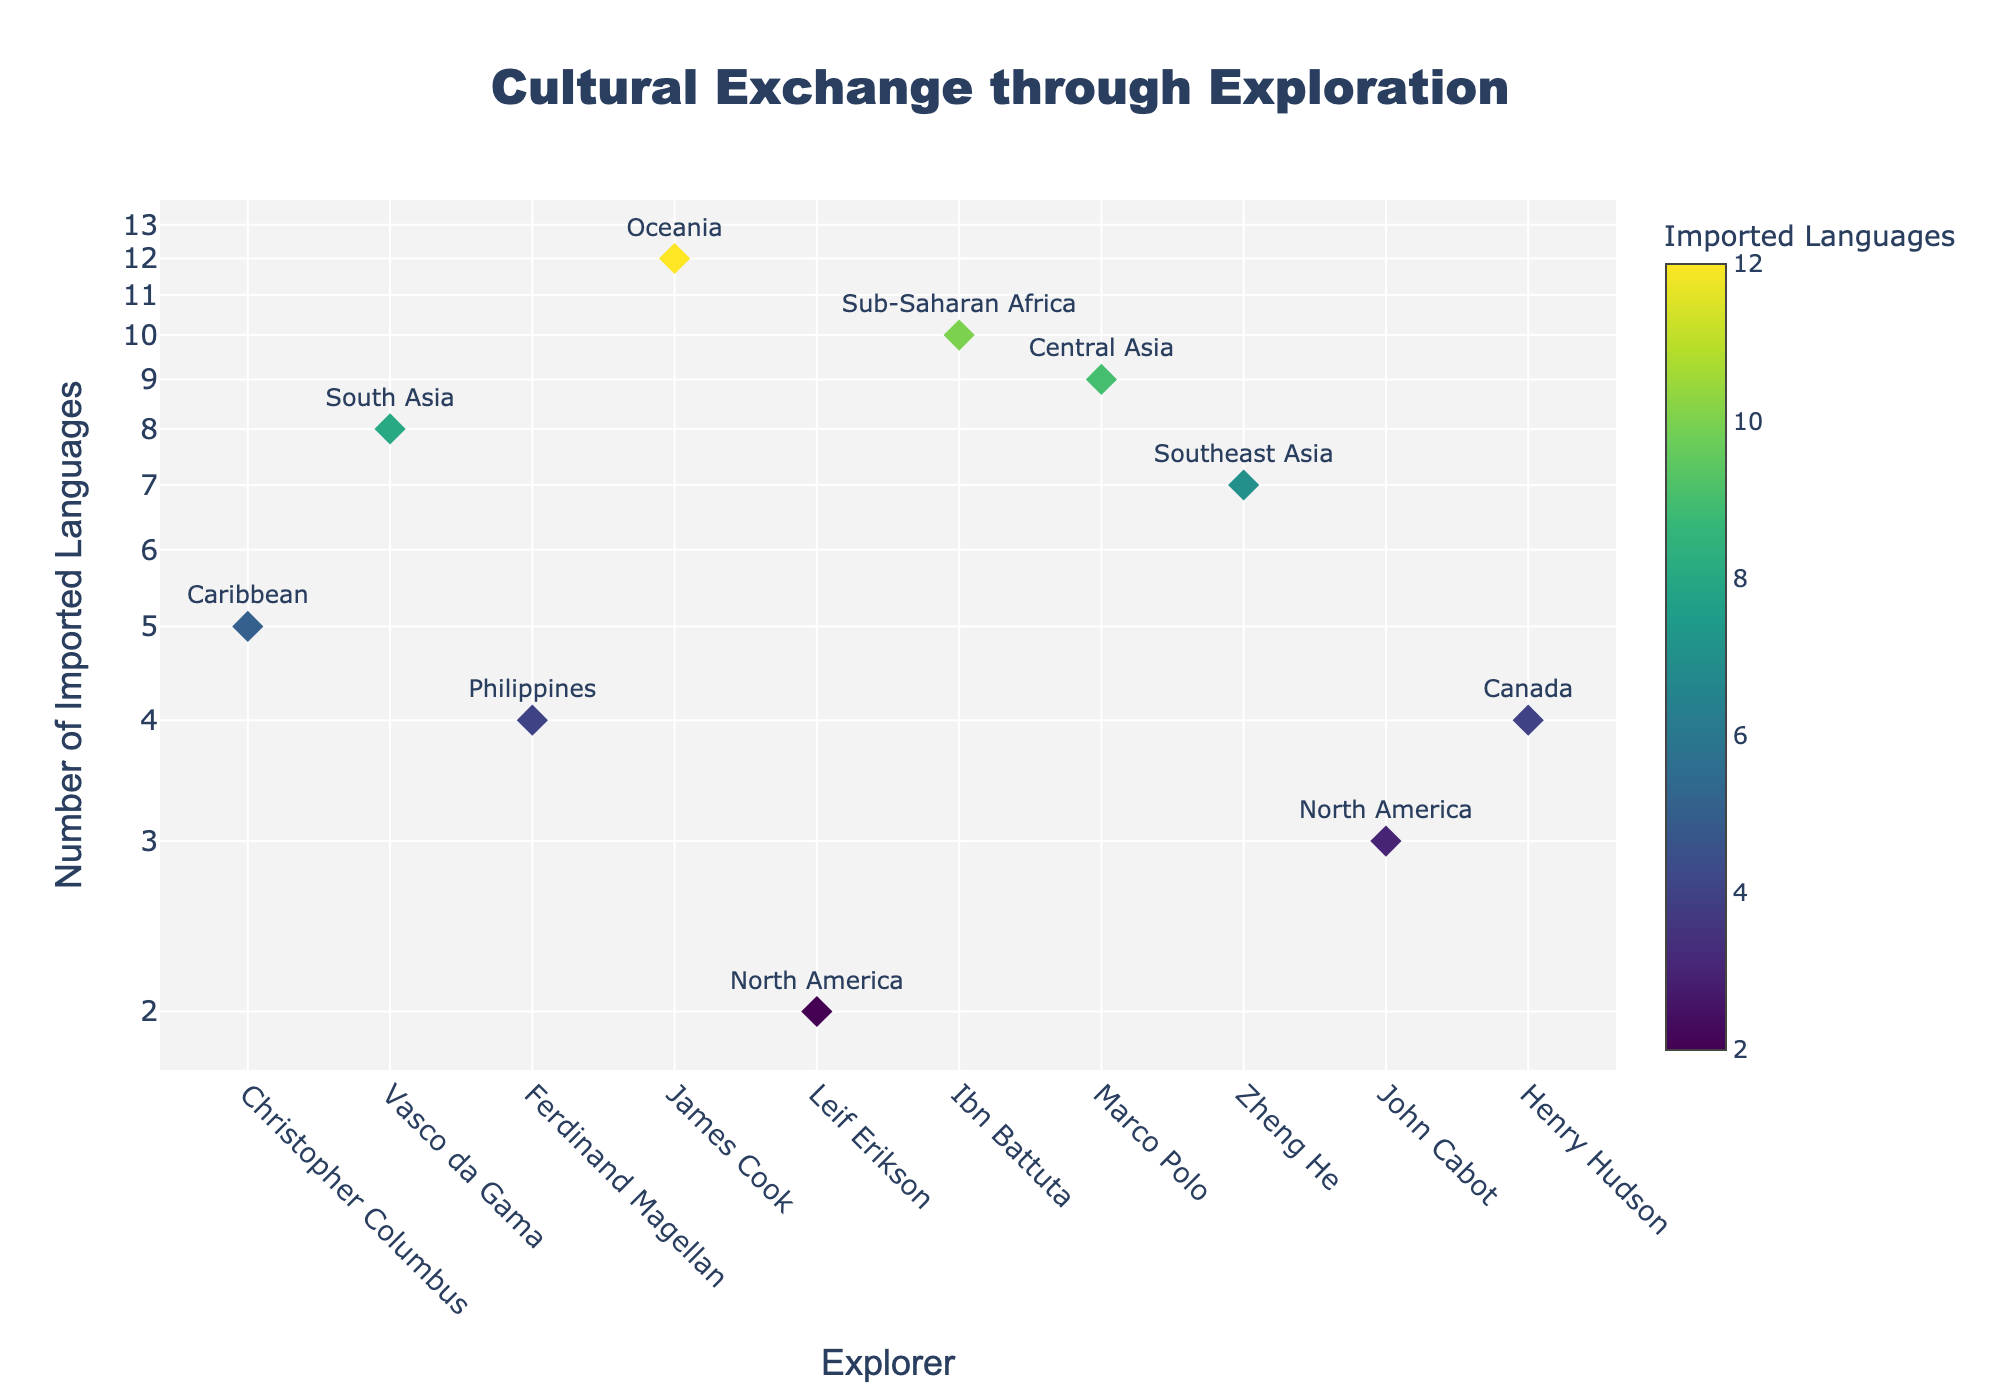What's the title of the scatter plot? The title is usually displayed at the top of the figure and is designed to provide an overview of what the plot is about. The title here reads "Cultural Exchange through Exploration".
Answer: Cultural Exchange through Exploration What are the axes titles of the scatter plot? Axes titles typically label the horizontal and vertical axes to explain what variables are being plotted. The horizontal axis title is "Explorer," and the vertical axis title is "Number of Imported Languages".
Answer: Explorer, Number of Imported Languages Which explorer shows the highest diversity of imported languages in indigenous texts? The point corresponding to the highest value on the y-axis (vertical axis) is labeled with a name. This is James Cook/Oceania with 12 imported languages.
Answer: James Cook On a log scale, which explorer has the fewest imported languages? The point corresponding to the lowest value on the y-axis represents the fewest imported languages. This value appears for Leif Erikson/North America with 2 imported languages.
Answer: Leif Erikson How many explorations resulted in 4 or more imported languages? Count the number of points on the scatter plot that have y-values (number of imported languages) of 4 or more. By observing the plot, there are 8 explorations (Vasco da Gama, James Cook, Ibn Battuta, Marco Polo, Zheng He, Magellan, John Cabot, Henry Hudson).
Answer: 8 What is the median value of the number of imported languages across all explorations? To find the median, list all y-values in ascending order (2, 3, 4, 4, 5, 7, 8, 9, 10, 12), and then pick the middle value. With an even number of observations, the median is the average of the 5th and 6th values, which are 5 and 7. Therefore, the median is (5 + 7)/2 = 6.
Answer: 6 Which explorers have equal numbers of imported languages documented? Look for overlapping y-values (vertical values). Ferdinand Magellan and Henry Hudson both have 4 imported languages.
Answer: Ferdinand Magellan, Henry Hudson Is there a positive correlation between the explorer and the number of imported languages? Checking the overall pattern on the scatter plot, one can see a trend that higher imported languages tend to align with specific explorers. This implies a positive correlation as more noted explorers tend to have more imported languages.
Answer: Yes Identify the region with the second highest number of imported languages. James Cook/Oceania has the highest number (12), followed by Ibn Battuta/Sub-Saharan Africa who has the second-highest number of imported languages (10).
Answer: Sub-Saharan Africa 